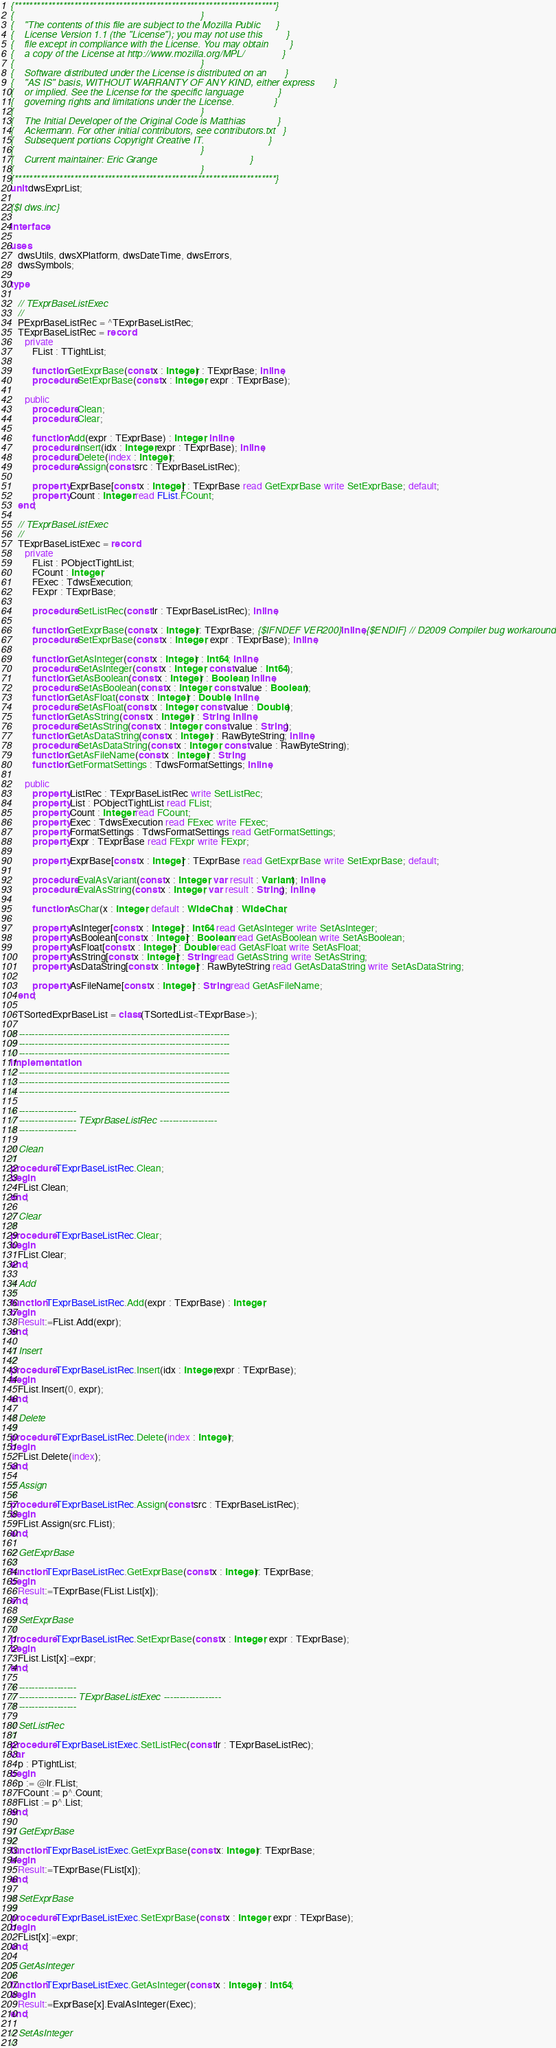Convert code to text. <code><loc_0><loc_0><loc_500><loc_500><_Pascal_>{**********************************************************************}
{                                                                      }
{    "The contents of this file are subject to the Mozilla Public      }
{    License Version 1.1 (the "License"); you may not use this         }
{    file except in compliance with the License. You may obtain        }
{    a copy of the License at http://www.mozilla.org/MPL/              }
{                                                                      }
{    Software distributed under the License is distributed on an       }
{    "AS IS" basis, WITHOUT WARRANTY OF ANY KIND, either express       }
{    or implied. See the License for the specific language             }
{    governing rights and limitations under the License.               }
{                                                                      }
{    The Initial Developer of the Original Code is Matthias            }
{    Ackermann. For other initial contributors, see contributors.txt   }
{    Subsequent portions Copyright Creative IT.                        }
{                                                                      }
{    Current maintainer: Eric Grange                                   }
{                                                                      }
{**********************************************************************}
unit dwsExprList;

{$I dws.inc}

interface

uses
   dwsUtils, dwsXPlatform, dwsDateTime, dwsErrors,
   dwsSymbols;

type

   // TExprBaseListExec
   //
   PExprBaseListRec = ^TExprBaseListRec;
   TExprBaseListRec = record
      private
         FList : TTightList;

         function GetExprBase(const x : Integer) : TExprBase; inline;
         procedure SetExprBase(const x : Integer; expr : TExprBase);

      public
         procedure Clean;
         procedure Clear;

         function Add(expr : TExprBase) : Integer; inline;
         procedure Insert(idx : Integer;expr : TExprBase); inline;
         procedure Delete(index : Integer);
         procedure Assign(const src : TExprBaseListRec);

         property ExprBase[const x : Integer] : TExprBase read GetExprBase write SetExprBase; default;
         property Count : Integer read FList.FCount;
   end;

   // TExprBaseListExec
   //
   TExprBaseListExec = record
      private
         FList : PObjectTightList;
         FCount : Integer;
         FExec : TdwsExecution;
         FExpr : TExprBase;

         procedure SetListRec(const lr : TExprBaseListRec); inline;

         function GetExprBase(const x : Integer): TExprBase; {$IFNDEF VER200}inline;{$ENDIF} // D2009 Compiler bug workaround
         procedure SetExprBase(const x : Integer; expr : TExprBase); inline;

         function GetAsInteger(const x : Integer) : Int64; inline;
         procedure SetAsInteger(const x : Integer; const value : Int64);
         function GetAsBoolean(const x : Integer) : Boolean; inline;
         procedure SetAsBoolean(const x : Integer; const value : Boolean);
         function GetAsFloat(const x : Integer) : Double; inline;
         procedure SetAsFloat(const x : Integer; const value : Double);
         function GetAsString(const x : Integer) : String; inline;
         procedure SetAsString(const x : Integer; const value : String);
         function GetAsDataString(const x : Integer) : RawByteString; inline;
         procedure SetAsDataString(const x : Integer; const value : RawByteString);
         function GetAsFileName(const x : Integer) : String;
         function GetFormatSettings : TdwsFormatSettings; inline;

      public
         property ListRec : TExprBaseListRec write SetListRec;
         property List : PObjectTightList read FList;
         property Count : Integer read FCount;
         property Exec : TdwsExecution read FExec write FExec;
         property FormatSettings : TdwsFormatSettings read GetFormatSettings;
         property Expr : TExprBase read FExpr write FExpr;

         property ExprBase[const x : Integer] : TExprBase read GetExprBase write SetExprBase; default;

         procedure EvalAsVariant(const x : Integer; var result : Variant); inline;
         procedure EvalAsString(const x : Integer; var result : String); inline;

         function AsChar(x : Integer; default : WideChar) : WideChar;

         property AsInteger[const x : Integer] : Int64 read GetAsInteger write SetAsInteger;
         property AsBoolean[const x : Integer] : Boolean read GetAsBoolean write SetAsBoolean;
         property AsFloat[const x : Integer] : Double read GetAsFloat write SetAsFloat;
         property AsString[const x : Integer] : String read GetAsString write SetAsString;
         property AsDataString[const x : Integer] : RawByteString read GetAsDataString write SetAsDataString;

         property AsFileName[const x : Integer] : String read GetAsFileName;
   end;

   TSortedExprBaseList = class(TSortedList<TExprBase>);

// ------------------------------------------------------------------
// ------------------------------------------------------------------
// ------------------------------------------------------------------
implementation
// ------------------------------------------------------------------
// ------------------------------------------------------------------
// ------------------------------------------------------------------

// ------------------
// ------------------ TExprBaseListRec ------------------
// ------------------

// Clean
//
procedure TExprBaseListRec.Clean;
begin
   FList.Clean;
end;

// Clear
//
procedure TExprBaseListRec.Clear;
begin
   FList.Clear;
end;

// Add
//
function TExprBaseListRec.Add(expr : TExprBase) : Integer;
begin
   Result:=FList.Add(expr);
end;

// Insert
//
procedure TExprBaseListRec.Insert(idx : Integer;expr : TExprBase);
begin
   FList.Insert(0, expr);
end;

// Delete
//
procedure TExprBaseListRec.Delete(index : Integer);
begin
   FList.Delete(index);
end;

// Assign
//
procedure TExprBaseListRec.Assign(const src : TExprBaseListRec);
begin
   FList.Assign(src.FList);
end;

// GetExprBase
//
function TExprBaseListRec.GetExprBase(const x : Integer): TExprBase;
begin
   Result:=TExprBase(FList.List[x]);
end;

// SetExprBase
//
procedure TExprBaseListRec.SetExprBase(const x : Integer; expr : TExprBase);
begin
   FList.List[x]:=expr;
end;

// ------------------
// ------------------ TExprBaseListExec ------------------
// ------------------

// SetListRec
//
procedure TExprBaseListExec.SetListRec(const lr : TExprBaseListRec);
var
   p : PTightList;
begin
   p := @lr.FList;
   FCount := p^.Count;
   FList := p^.List;
end;

// GetExprBase
//
function TExprBaseListExec.GetExprBase(const x: Integer): TExprBase;
begin
   Result:=TExprBase(FList[x]);
end;

// SetExprBase
//
procedure TExprBaseListExec.SetExprBase(const x : Integer; expr : TExprBase);
begin
   FList[x]:=expr;
end;

// GetAsInteger
//
function TExprBaseListExec.GetAsInteger(const x : Integer) : Int64;
begin
   Result:=ExprBase[x].EvalAsInteger(Exec);
end;

// SetAsInteger
//</code> 